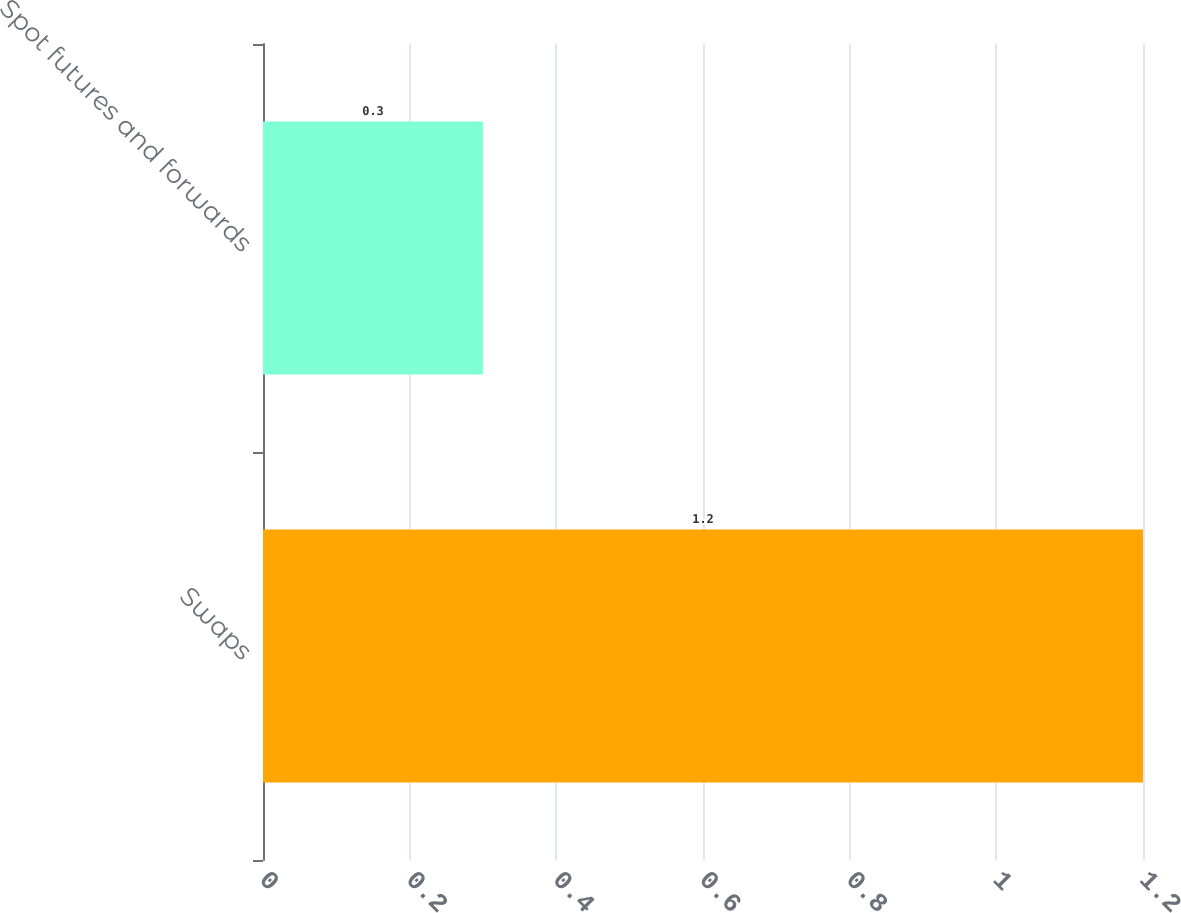Convert chart to OTSL. <chart><loc_0><loc_0><loc_500><loc_500><bar_chart><fcel>Swaps<fcel>Spot futures and forwards<nl><fcel>1.2<fcel>0.3<nl></chart> 